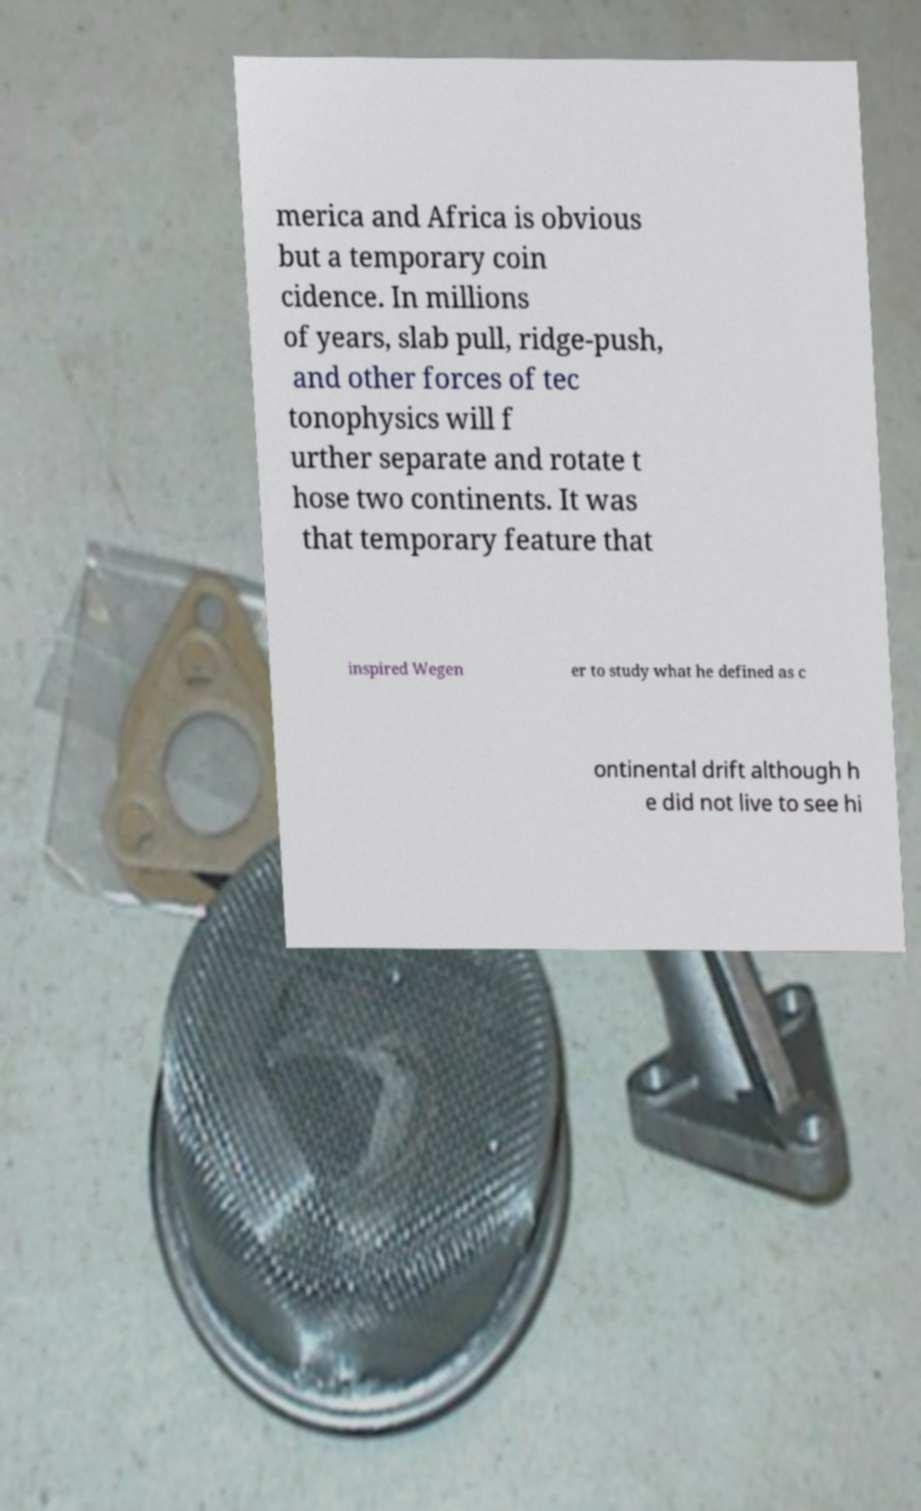What messages or text are displayed in this image? I need them in a readable, typed format. merica and Africa is obvious but a temporary coin cidence. In millions of years, slab pull, ridge-push, and other forces of tec tonophysics will f urther separate and rotate t hose two continents. It was that temporary feature that inspired Wegen er to study what he defined as c ontinental drift although h e did not live to see hi 